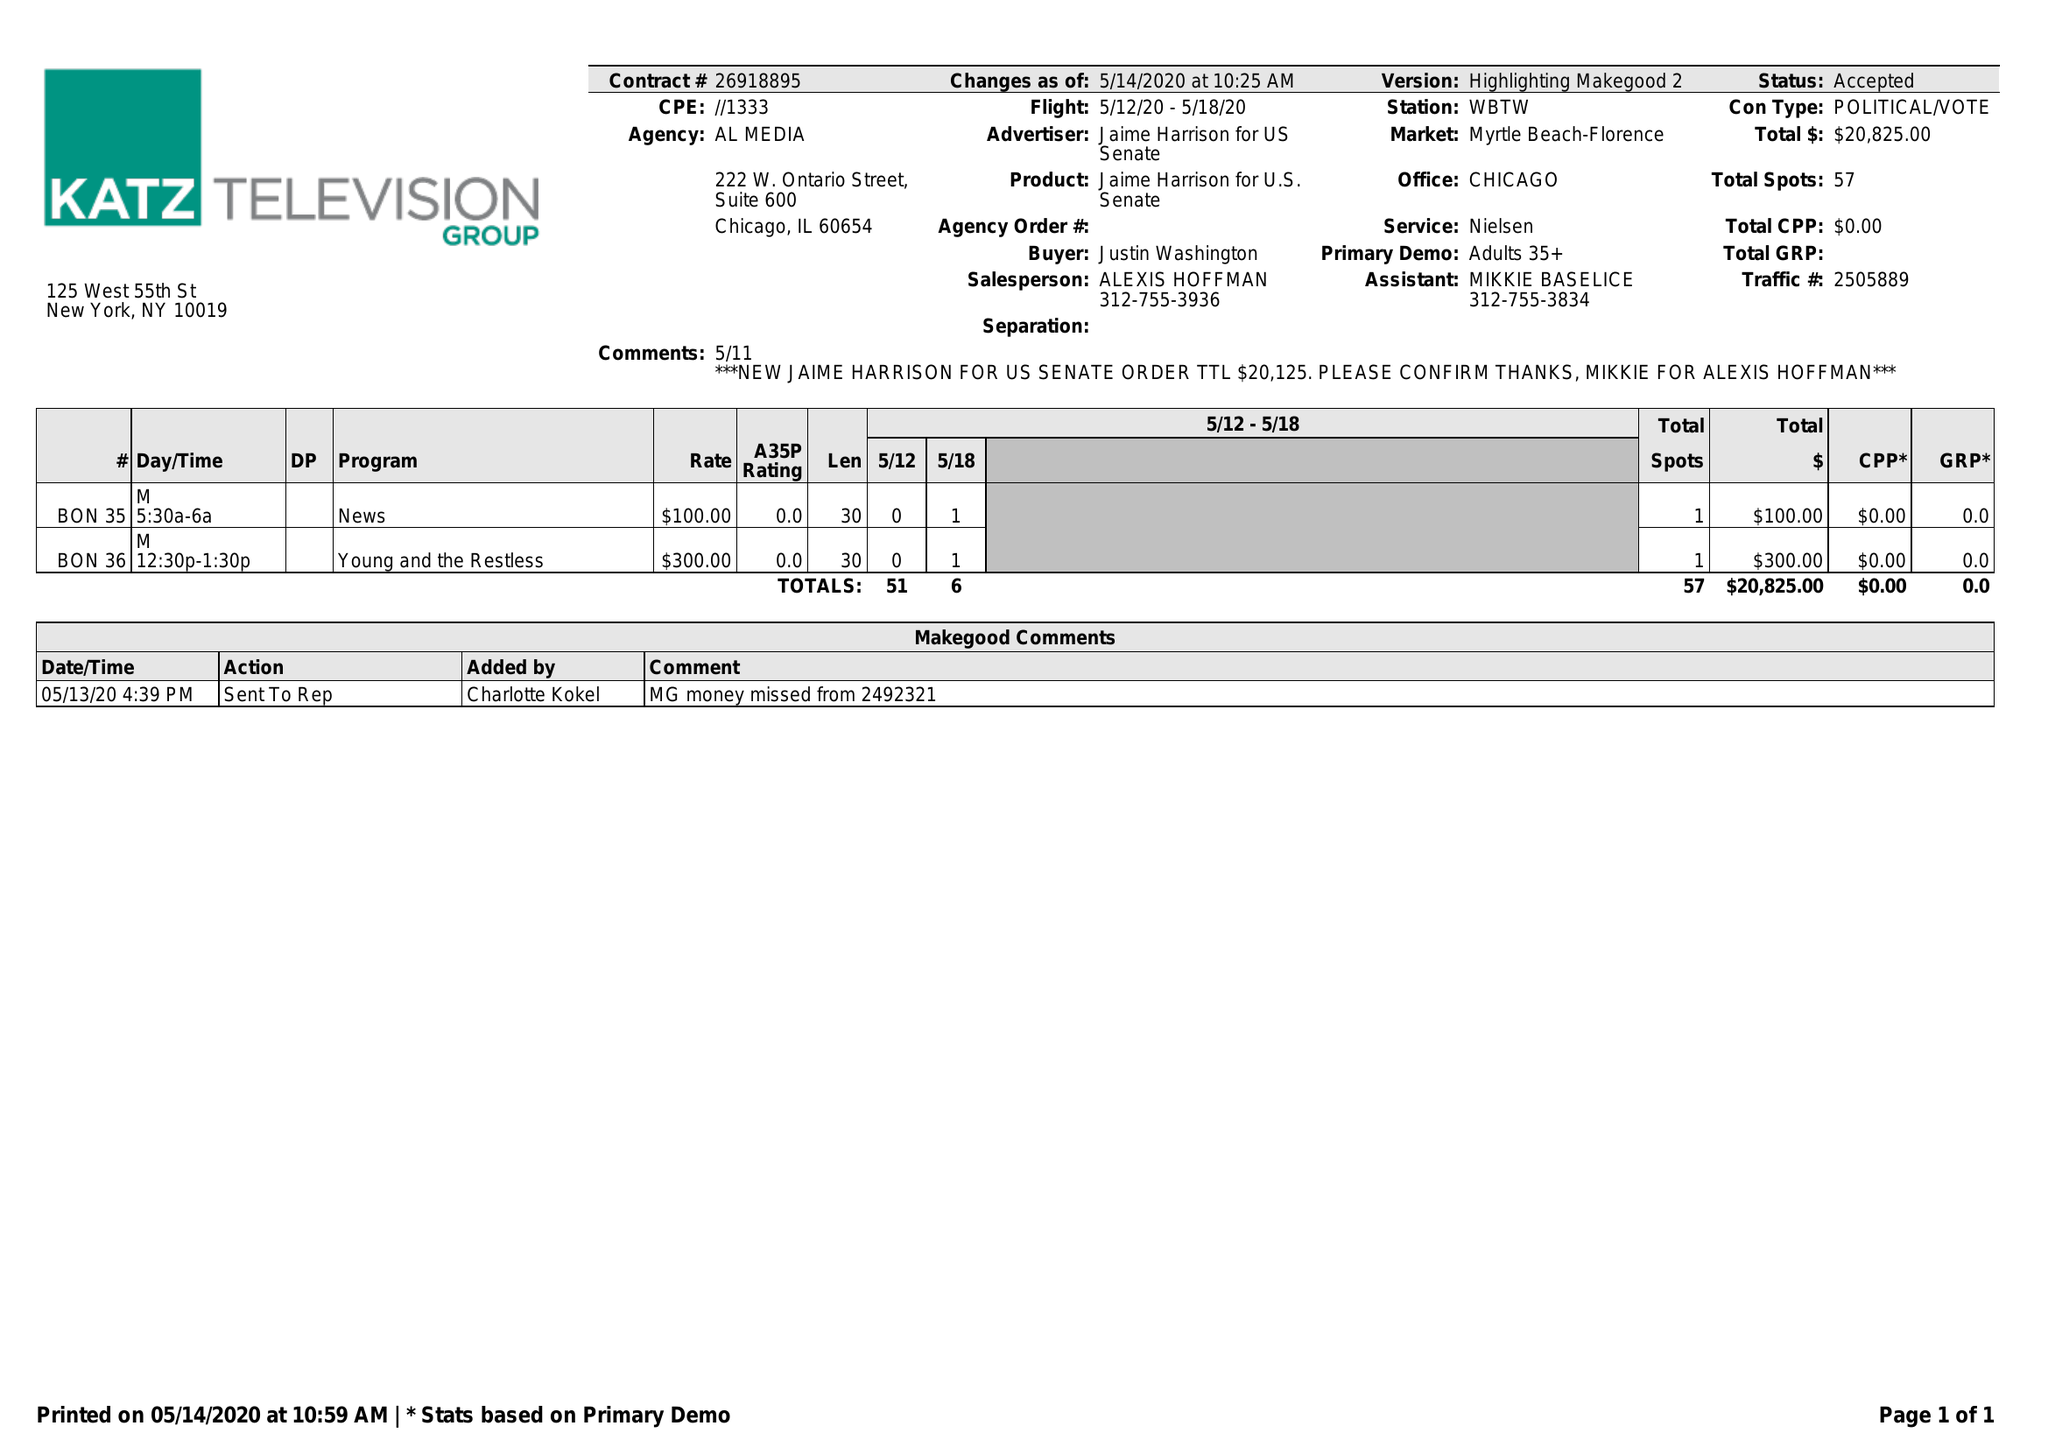What is the value for the flight_to?
Answer the question using a single word or phrase. 05/18/20 